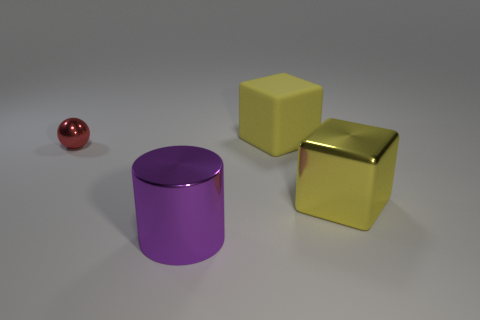Are there more big yellow things behind the red object than purple shiny cylinders behind the big yellow shiny object?
Make the answer very short. Yes. The matte object that is the same size as the purple metal cylinder is what color?
Your answer should be compact. Yellow. Are there any small metallic things of the same color as the big rubber object?
Ensure brevity in your answer.  No. There is a big block in front of the large rubber thing; is it the same color as the object on the left side of the large purple shiny object?
Your answer should be compact. No. What is the large yellow thing behind the tiny red metal object made of?
Your answer should be very brief. Rubber. There is a cylinder that is made of the same material as the small thing; what is its color?
Keep it short and to the point. Purple. How many purple metal objects have the same size as the red metallic ball?
Keep it short and to the point. 0. There is a shiny thing that is behind the yellow metallic object; is it the same size as the big rubber cube?
Offer a very short reply. No. There is a thing that is both in front of the tiny red metallic ball and left of the yellow matte block; what shape is it?
Your response must be concise. Cylinder. There is a yellow shiny cube; are there any things to the right of it?
Ensure brevity in your answer.  No. 